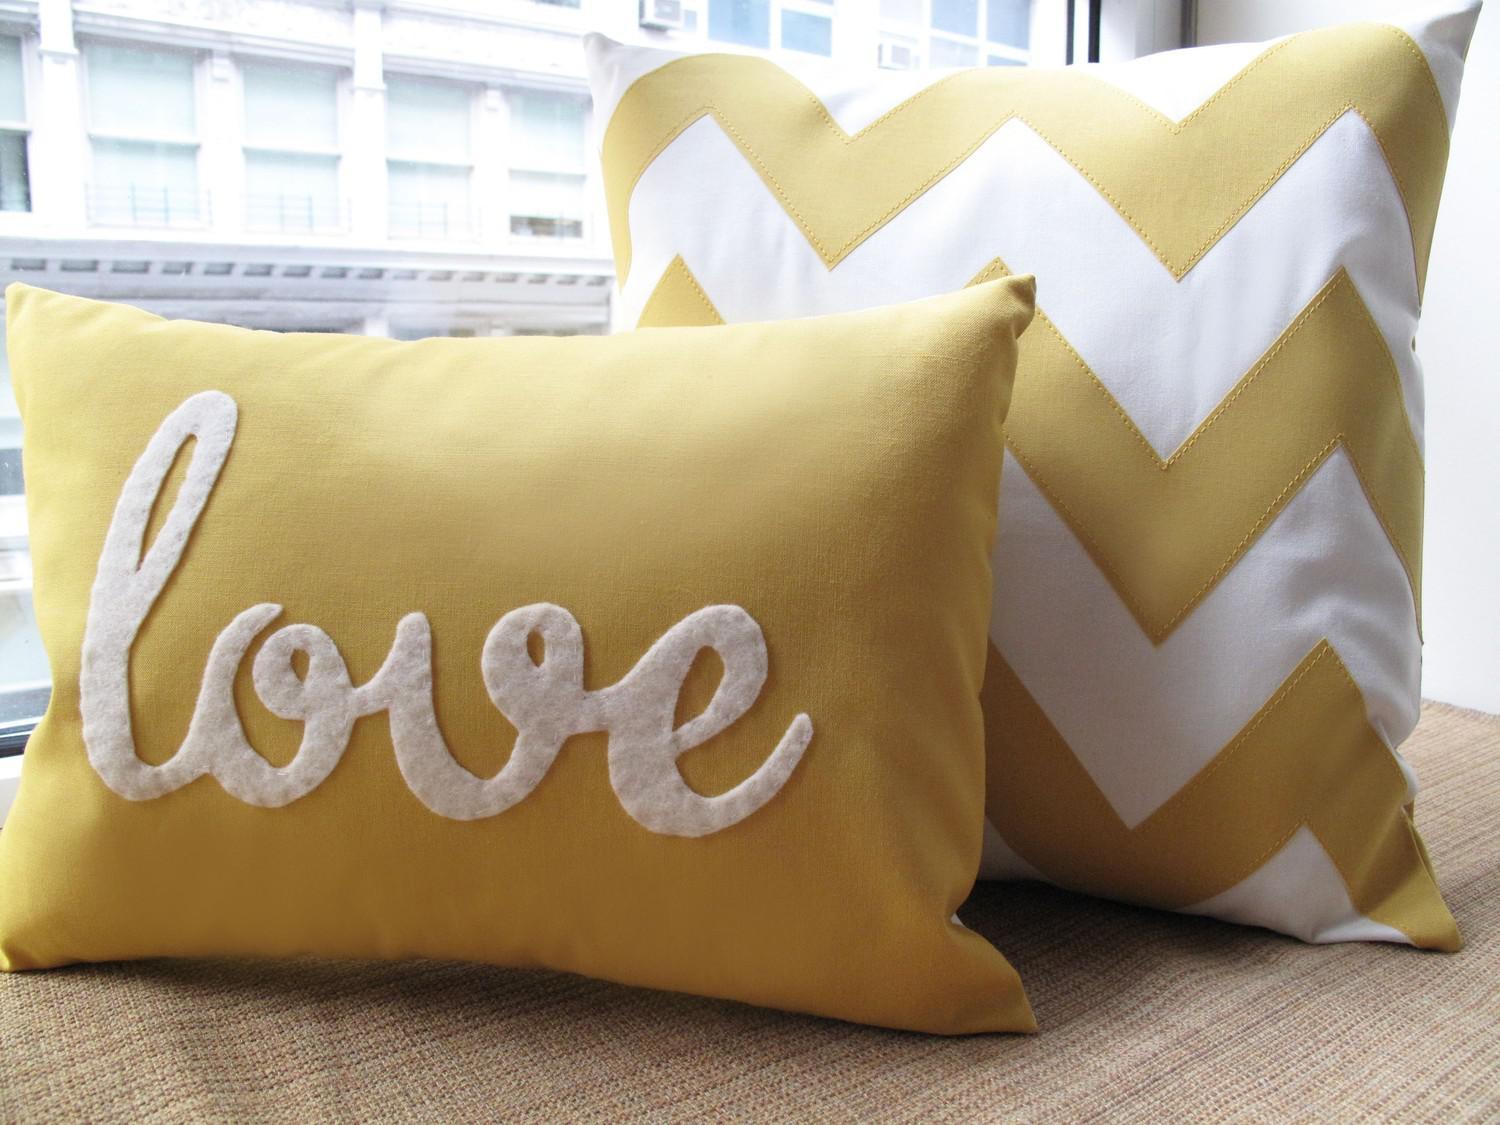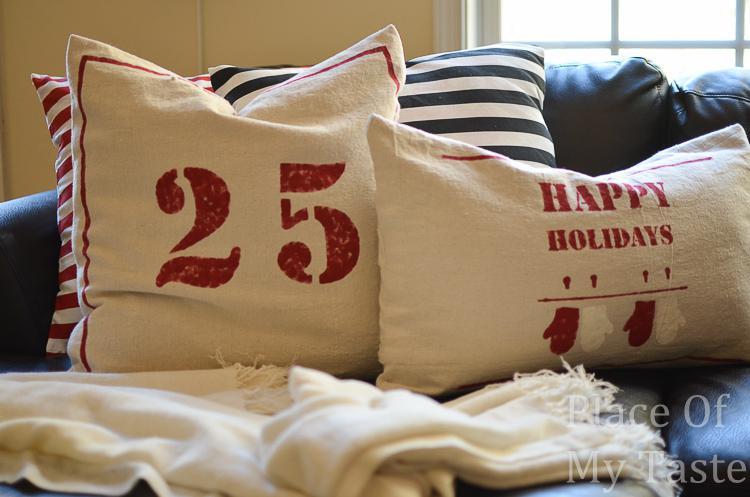The first image is the image on the left, the second image is the image on the right. Examine the images to the left and right. Is the description "All images include at least one pillow with text on it, and one image also includes two striped pillows." accurate? Answer yes or no. Yes. The first image is the image on the left, the second image is the image on the right. Given the left and right images, does the statement "There are at least 7 pillows." hold true? Answer yes or no. No. The first image is the image on the left, the second image is the image on the right. Evaluate the accuracy of this statement regarding the images: "The righthand image includes striped pillows and a pillow with mitten pairs stamped on it.". Is it true? Answer yes or no. Yes. 